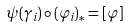Convert formula to latex. <formula><loc_0><loc_0><loc_500><loc_500>\psi ( \gamma _ { i } ) \circ ( \varphi _ { i } ) _ { * } = [ \varphi ]</formula> 